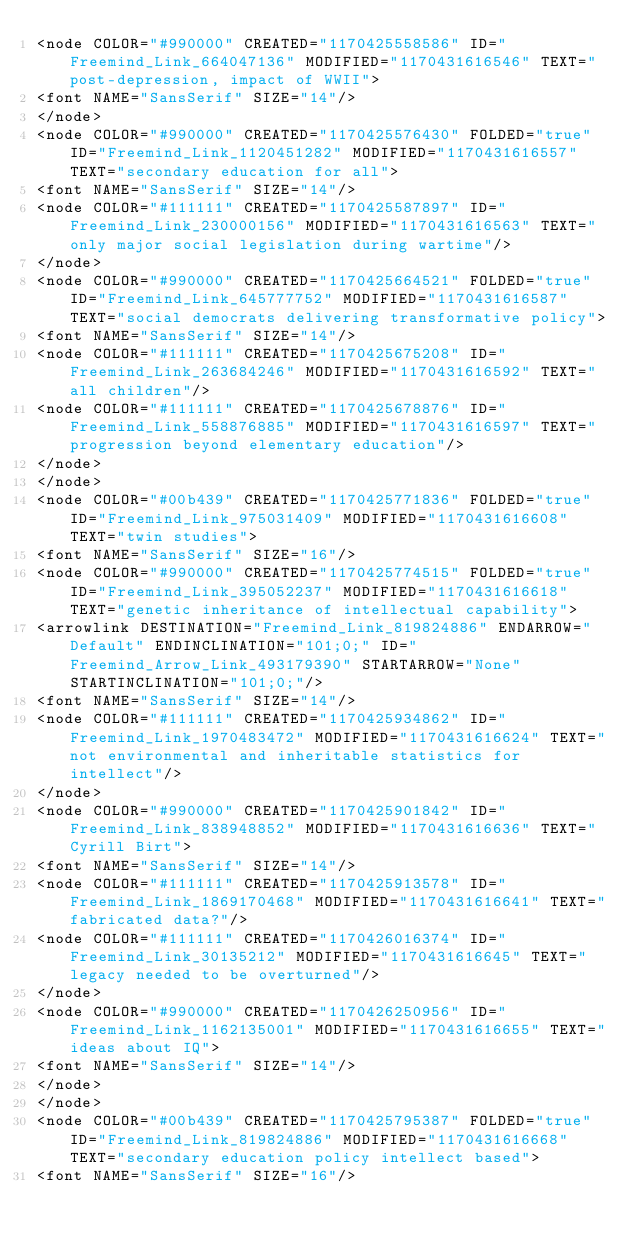<code> <loc_0><loc_0><loc_500><loc_500><_ObjectiveC_><node COLOR="#990000" CREATED="1170425558586" ID="Freemind_Link_664047136" MODIFIED="1170431616546" TEXT="post-depression, impact of WWII">
<font NAME="SansSerif" SIZE="14"/>
</node>
<node COLOR="#990000" CREATED="1170425576430" FOLDED="true" ID="Freemind_Link_1120451282" MODIFIED="1170431616557" TEXT="secondary education for all">
<font NAME="SansSerif" SIZE="14"/>
<node COLOR="#111111" CREATED="1170425587897" ID="Freemind_Link_230000156" MODIFIED="1170431616563" TEXT="only major social legislation during wartime"/>
</node>
<node COLOR="#990000" CREATED="1170425664521" FOLDED="true" ID="Freemind_Link_645777752" MODIFIED="1170431616587" TEXT="social democrats delivering transformative policy">
<font NAME="SansSerif" SIZE="14"/>
<node COLOR="#111111" CREATED="1170425675208" ID="Freemind_Link_263684246" MODIFIED="1170431616592" TEXT="all children"/>
<node COLOR="#111111" CREATED="1170425678876" ID="Freemind_Link_558876885" MODIFIED="1170431616597" TEXT="progression beyond elementary education"/>
</node>
</node>
<node COLOR="#00b439" CREATED="1170425771836" FOLDED="true" ID="Freemind_Link_975031409" MODIFIED="1170431616608" TEXT="twin studies">
<font NAME="SansSerif" SIZE="16"/>
<node COLOR="#990000" CREATED="1170425774515" FOLDED="true" ID="Freemind_Link_395052237" MODIFIED="1170431616618" TEXT="genetic inheritance of intellectual capability">
<arrowlink DESTINATION="Freemind_Link_819824886" ENDARROW="Default" ENDINCLINATION="101;0;" ID="Freemind_Arrow_Link_493179390" STARTARROW="None" STARTINCLINATION="101;0;"/>
<font NAME="SansSerif" SIZE="14"/>
<node COLOR="#111111" CREATED="1170425934862" ID="Freemind_Link_1970483472" MODIFIED="1170431616624" TEXT="not environmental and inheritable statistics for intellect"/>
</node>
<node COLOR="#990000" CREATED="1170425901842" ID="Freemind_Link_838948852" MODIFIED="1170431616636" TEXT="Cyrill Birt">
<font NAME="SansSerif" SIZE="14"/>
<node COLOR="#111111" CREATED="1170425913578" ID="Freemind_Link_1869170468" MODIFIED="1170431616641" TEXT="fabricated data?"/>
<node COLOR="#111111" CREATED="1170426016374" ID="Freemind_Link_30135212" MODIFIED="1170431616645" TEXT="legacy needed to be overturned"/>
</node>
<node COLOR="#990000" CREATED="1170426250956" ID="Freemind_Link_1162135001" MODIFIED="1170431616655" TEXT="ideas about IQ">
<font NAME="SansSerif" SIZE="14"/>
</node>
</node>
<node COLOR="#00b439" CREATED="1170425795387" FOLDED="true" ID="Freemind_Link_819824886" MODIFIED="1170431616668" TEXT="secondary education policy intellect based">
<font NAME="SansSerif" SIZE="16"/></code> 